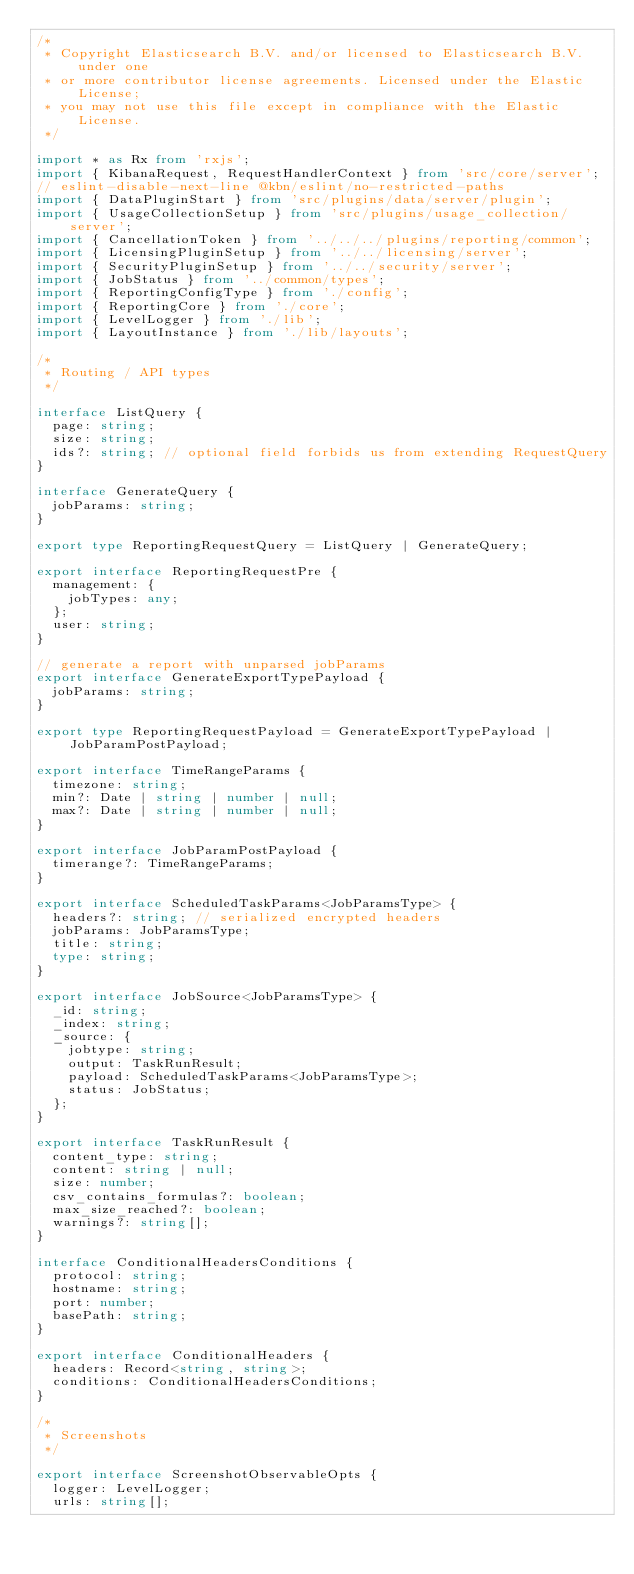Convert code to text. <code><loc_0><loc_0><loc_500><loc_500><_TypeScript_>/*
 * Copyright Elasticsearch B.V. and/or licensed to Elasticsearch B.V. under one
 * or more contributor license agreements. Licensed under the Elastic License;
 * you may not use this file except in compliance with the Elastic License.
 */

import * as Rx from 'rxjs';
import { KibanaRequest, RequestHandlerContext } from 'src/core/server';
// eslint-disable-next-line @kbn/eslint/no-restricted-paths
import { DataPluginStart } from 'src/plugins/data/server/plugin';
import { UsageCollectionSetup } from 'src/plugins/usage_collection/server';
import { CancellationToken } from '../../../plugins/reporting/common';
import { LicensingPluginSetup } from '../../licensing/server';
import { SecurityPluginSetup } from '../../security/server';
import { JobStatus } from '../common/types';
import { ReportingConfigType } from './config';
import { ReportingCore } from './core';
import { LevelLogger } from './lib';
import { LayoutInstance } from './lib/layouts';

/*
 * Routing / API types
 */

interface ListQuery {
  page: string;
  size: string;
  ids?: string; // optional field forbids us from extending RequestQuery
}

interface GenerateQuery {
  jobParams: string;
}

export type ReportingRequestQuery = ListQuery | GenerateQuery;

export interface ReportingRequestPre {
  management: {
    jobTypes: any;
  };
  user: string;
}

// generate a report with unparsed jobParams
export interface GenerateExportTypePayload {
  jobParams: string;
}

export type ReportingRequestPayload = GenerateExportTypePayload | JobParamPostPayload;

export interface TimeRangeParams {
  timezone: string;
  min?: Date | string | number | null;
  max?: Date | string | number | null;
}

export interface JobParamPostPayload {
  timerange?: TimeRangeParams;
}

export interface ScheduledTaskParams<JobParamsType> {
  headers?: string; // serialized encrypted headers
  jobParams: JobParamsType;
  title: string;
  type: string;
}

export interface JobSource<JobParamsType> {
  _id: string;
  _index: string;
  _source: {
    jobtype: string;
    output: TaskRunResult;
    payload: ScheduledTaskParams<JobParamsType>;
    status: JobStatus;
  };
}

export interface TaskRunResult {
  content_type: string;
  content: string | null;
  size: number;
  csv_contains_formulas?: boolean;
  max_size_reached?: boolean;
  warnings?: string[];
}

interface ConditionalHeadersConditions {
  protocol: string;
  hostname: string;
  port: number;
  basePath: string;
}

export interface ConditionalHeaders {
  headers: Record<string, string>;
  conditions: ConditionalHeadersConditions;
}

/*
 * Screenshots
 */

export interface ScreenshotObservableOpts {
  logger: LevelLogger;
  urls: string[];</code> 